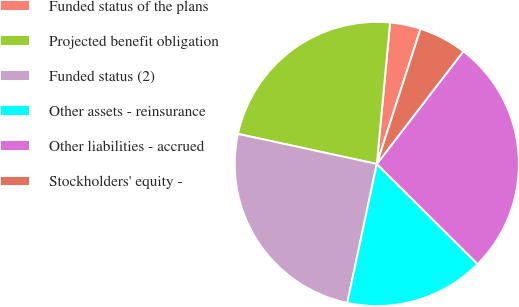<chart> <loc_0><loc_0><loc_500><loc_500><pie_chart><fcel>Funded status of the plans<fcel>Projected benefit obligation<fcel>Funded status (2)<fcel>Other assets - reinsurance<fcel>Other liabilities - accrued<fcel>Stockholders' equity -<nl><fcel>3.49%<fcel>23.1%<fcel>25.06%<fcel>15.89%<fcel>27.02%<fcel>5.45%<nl></chart> 